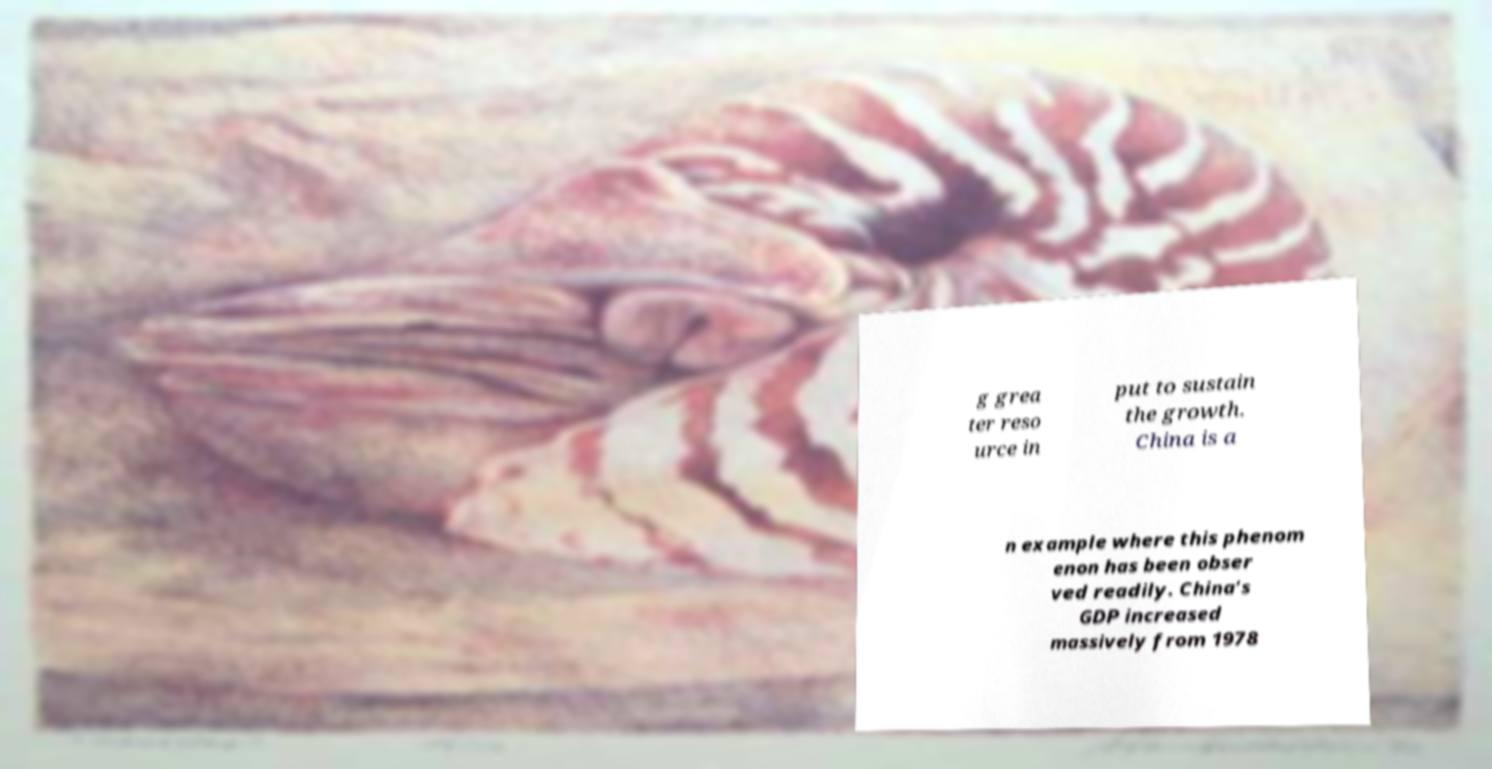Please identify and transcribe the text found in this image. g grea ter reso urce in put to sustain the growth. China is a n example where this phenom enon has been obser ved readily. China’s GDP increased massively from 1978 